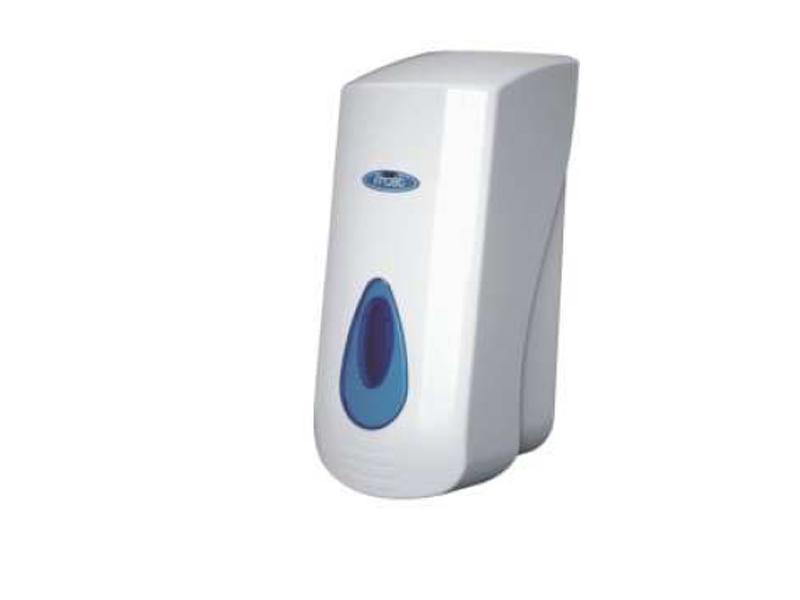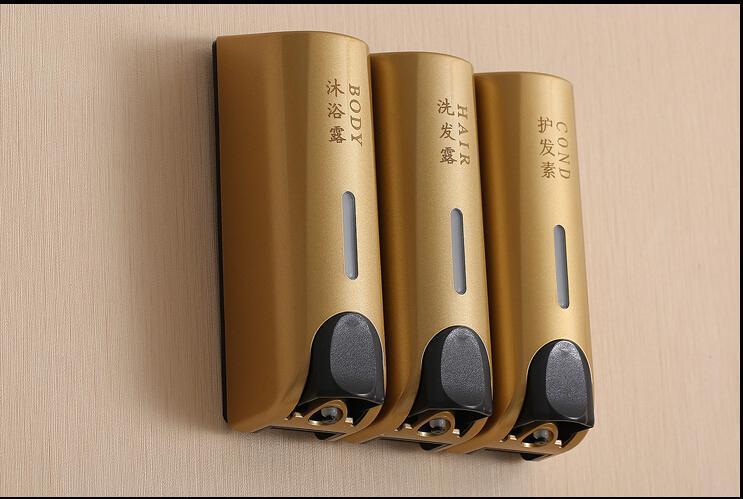The first image is the image on the left, the second image is the image on the right. Analyze the images presented: Is the assertion "There are at least two dispensers in the image on the right." valid? Answer yes or no. Yes. 